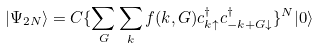Convert formula to latex. <formula><loc_0><loc_0><loc_500><loc_500>| \Psi _ { 2 N } \rangle = C \{ \sum _ { G } \sum _ { k } f ( k , G ) c ^ { \dagger } _ { k \uparrow } c ^ { \dagger } _ { - k + G \downarrow } \} ^ { N } | 0 \rangle</formula> 